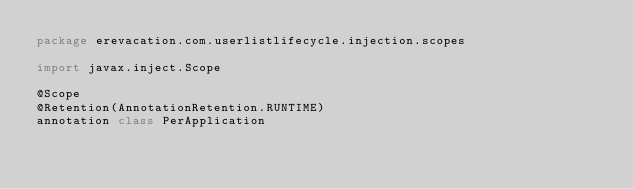<code> <loc_0><loc_0><loc_500><loc_500><_Kotlin_>package erevacation.com.userlistlifecycle.injection.scopes

import javax.inject.Scope

@Scope
@Retention(AnnotationRetention.RUNTIME)
annotation class PerApplication</code> 